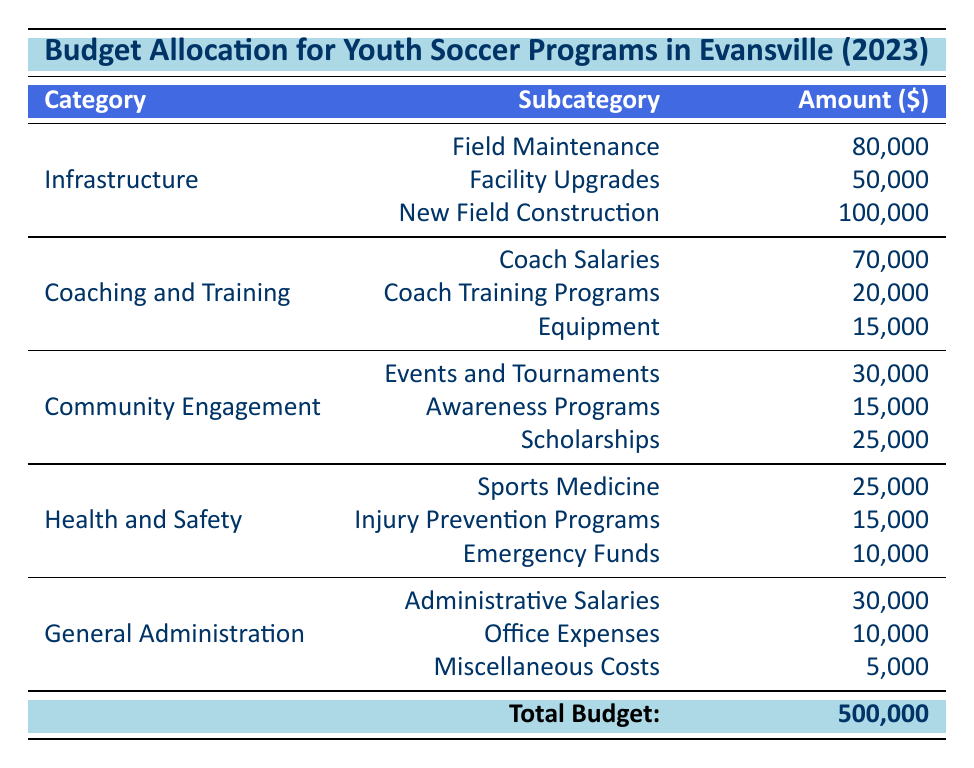What is the total budget allocated for youth soccer programs in Evansville for 2023? The total budget is explicitly stated at the bottom of the table, which is 500,000.
Answer: 500,000 How much money is allocated for new field construction? The amount allocated for new field construction is listed under the Infrastructure category, which is 100,000.
Answer: 100,000 What is the combined budget for coaching and training? To find the combined budget for coaching and training, we add the amounts for coach salaries (70,000), coach training programs (20,000), and equipment (15,000): 70,000 + 20,000 + 15,000 = 105,000.
Answer: 105,000 Is the amount allocated for emergency funds greater than that for scholarships? The amount for emergency funds is 10,000 and for scholarships is 25,000. Since 10,000 is not greater than 25,000, the answer is no.
Answer: No Which category receives the least amount of budget allocation? The General Administration category has the lowest individual allocations when summed: administrative salaries (30,000), office expenses (10,000), and miscellaneous costs (5,000), leading to a total of 45,000. Comparatively, other categories have higher totals.
Answer: General Administration In which category is a higher amount allocated: Community Engagement or Health and Safety? The total for Community Engagement is: events and tournaments (30,000) + awareness programs (15,000) + scholarships (25,000) = 70,000. For Health and Safety, the total is: sports medicine (25,000) + injury prevention programs (15,000) + emergency funds (10,000) = 50,000. Since 70,000 is greater than 50,000, the answer is Community Engagement.
Answer: Community Engagement What percentage of the total budget is allocated for field maintenance? The field maintenance amount is 80,000. To calculate the percentage, we take (80,000 / 500,000) * 100 = 16%.
Answer: 16% What is the difference between the budget for facility upgrades and emergency funds? The amount for facility upgrades is 50,000 and for emergency funds is 10,000. The difference is 50,000 - 10,000 = 40,000.
Answer: 40,000 Are there more funds allocated for Events and Tournaments compared to Sports Medicine? The funds for Events and Tournaments is 30,000 while for Sports Medicine it is 25,000. Since 30,000 is greater than 25,000, the answer is yes.
Answer: Yes 